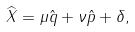<formula> <loc_0><loc_0><loc_500><loc_500>\widehat { X } = \mu \hat { q } + \nu \hat { p } + \delta ,</formula> 